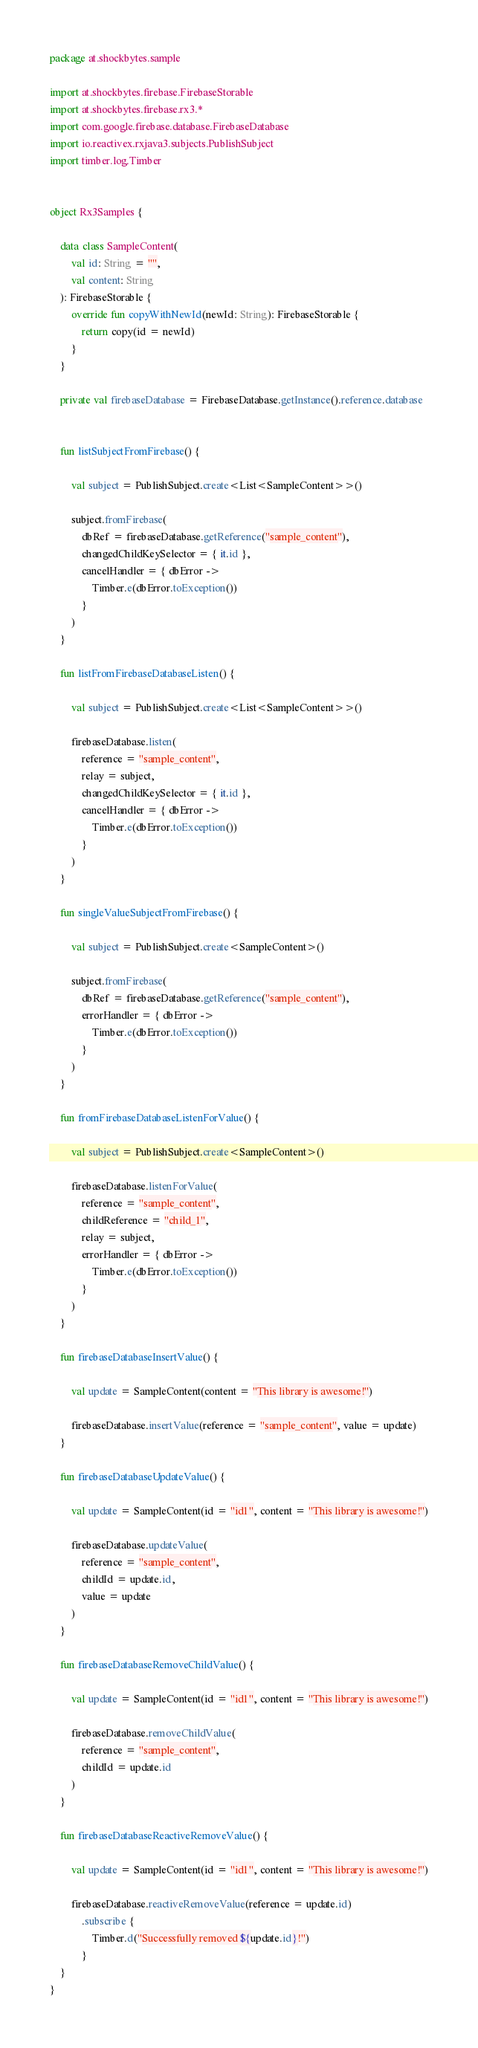Convert code to text. <code><loc_0><loc_0><loc_500><loc_500><_Kotlin_>package at.shockbytes.sample

import at.shockbytes.firebase.FirebaseStorable
import at.shockbytes.firebase.rx3.*
import com.google.firebase.database.FirebaseDatabase
import io.reactivex.rxjava3.subjects.PublishSubject
import timber.log.Timber


object Rx3Samples {

    data class SampleContent(
        val id: String = "",
        val content: String
    ): FirebaseStorable {
        override fun copyWithNewId(newId: String): FirebaseStorable {
            return copy(id = newId)
        }
    }

    private val firebaseDatabase = FirebaseDatabase.getInstance().reference.database


    fun listSubjectFromFirebase() {

        val subject = PublishSubject.create<List<SampleContent>>()

        subject.fromFirebase(
            dbRef = firebaseDatabase.getReference("sample_content"),
            changedChildKeySelector = { it.id },
            cancelHandler = { dbError ->
                Timber.e(dbError.toException())
            }
        )
    }

    fun listFromFirebaseDatabaseListen() {

        val subject = PublishSubject.create<List<SampleContent>>()

        firebaseDatabase.listen(
            reference = "sample_content",
            relay = subject,
            changedChildKeySelector = { it.id },
            cancelHandler = { dbError ->
                Timber.e(dbError.toException())
            }
        )
    }

    fun singleValueSubjectFromFirebase() {

        val subject = PublishSubject.create<SampleContent>()

        subject.fromFirebase(
            dbRef = firebaseDatabase.getReference("sample_content"),
            errorHandler = { dbError ->
                Timber.e(dbError.toException())
            }
        )
    }

    fun fromFirebaseDatabaseListenForValue() {

        val subject = PublishSubject.create<SampleContent>()

        firebaseDatabase.listenForValue(
            reference = "sample_content",
            childReference = "child_1",
            relay = subject,
            errorHandler = { dbError ->
                Timber.e(dbError.toException())
            }
        )
    }

    fun firebaseDatabaseInsertValue() {

        val update = SampleContent(content = "This library is awesome!")

        firebaseDatabase.insertValue(reference = "sample_content", value = update)
    }

    fun firebaseDatabaseUpdateValue() {

        val update = SampleContent(id = "id1", content = "This library is awesome!")

        firebaseDatabase.updateValue(
            reference = "sample_content",
            childId = update.id,
            value = update
        )
    }

    fun firebaseDatabaseRemoveChildValue() {

        val update = SampleContent(id = "id1", content = "This library is awesome!")

        firebaseDatabase.removeChildValue(
            reference = "sample_content",
            childId = update.id
        )
    }

    fun firebaseDatabaseReactiveRemoveValue() {

        val update = SampleContent(id = "id1", content = "This library is awesome!")

        firebaseDatabase.reactiveRemoveValue(reference = update.id)
            .subscribe {
                Timber.d("Successfully removed ${update.id}!")
            }
    }
}</code> 